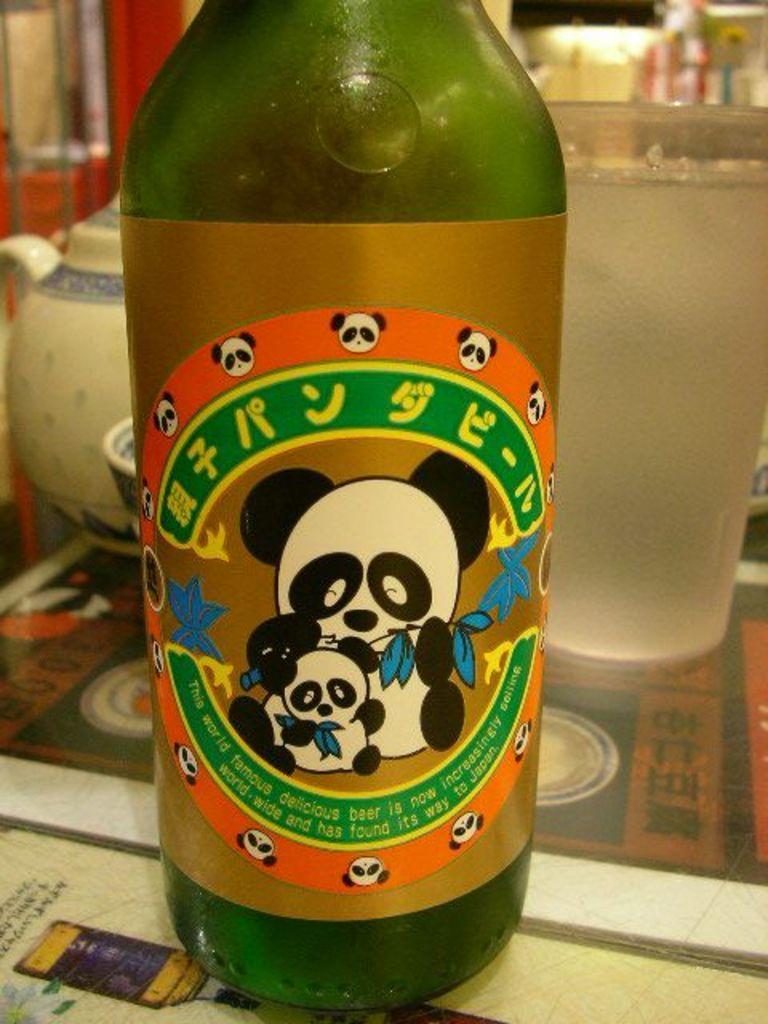Could you give a brief overview of what you see in this image? there is a green bottle on the table. behind that a glass is present. 